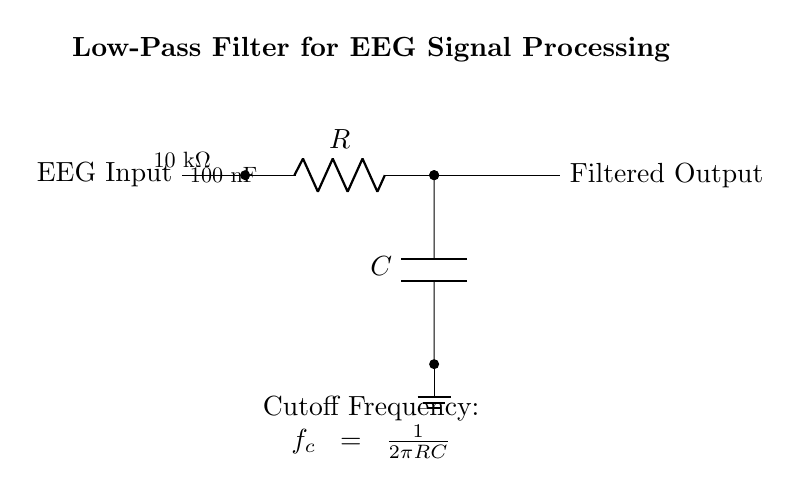What type of filter is represented in the circuit? The circuit is a low-pass filter, which allows signals with a frequency lower than a certain cutoff frequency to pass through while attenuating higher frequencies.
Answer: Low-pass filter What are the values of the resistor and capacitor in the circuit? The circuit specifies a resistor value of ten thousand ohms and a capacitor value of one hundred nanofarads.
Answer: 10 kΩ and 100 nF What is the purpose of the capacitor in this circuit? The capacitor in this circuit is used to store charge temporarily and, combined with the resistor, forms the low-pass filter that helps filter out high-frequency noise from the EEG signal.
Answer: Filtering high frequencies How is the cutoff frequency calculated for this circuit? The cutoff frequency is calculated using the formula f_c = 1/(2πRC), where R is the resistance and C is the capacitance. This mathematical relationship indicates how both components together determine the frequency at which the filter begins to attenuate the signal.
Answer: f_c = 1/(2πRC) What happens to high-frequency signals in this low-pass filter? High-frequency signals are attenuated or reduced in amplitude as they are not able to pass through effectively while low-frequency signals are allowed to pass through almost unchanged.
Answer: Attenuated Which component is directly connected to the EEG input? The resistor is the first component connected to the EEG input, indicating that it plays a critical role in the filtering process.
Answer: Resistor 